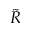Convert formula to latex. <formula><loc_0><loc_0><loc_500><loc_500>\tilde { R }</formula> 